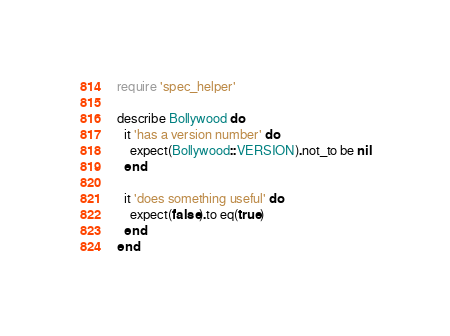<code> <loc_0><loc_0><loc_500><loc_500><_Ruby_>require 'spec_helper'

describe Bollywood do
  it 'has a version number' do
    expect(Bollywood::VERSION).not_to be nil
  end

  it 'does something useful' do
    expect(false).to eq(true)
  end
end
</code> 